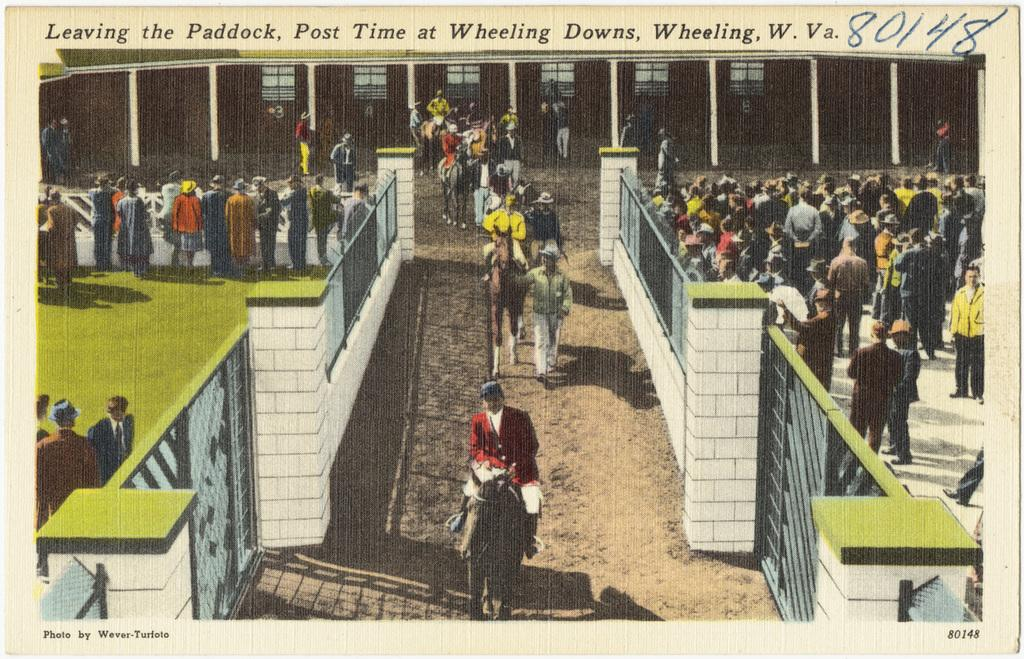<image>
Provide a brief description of the given image. a horse show photo that says 'leaving on paddock' on it 